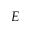<formula> <loc_0><loc_0><loc_500><loc_500>E</formula> 